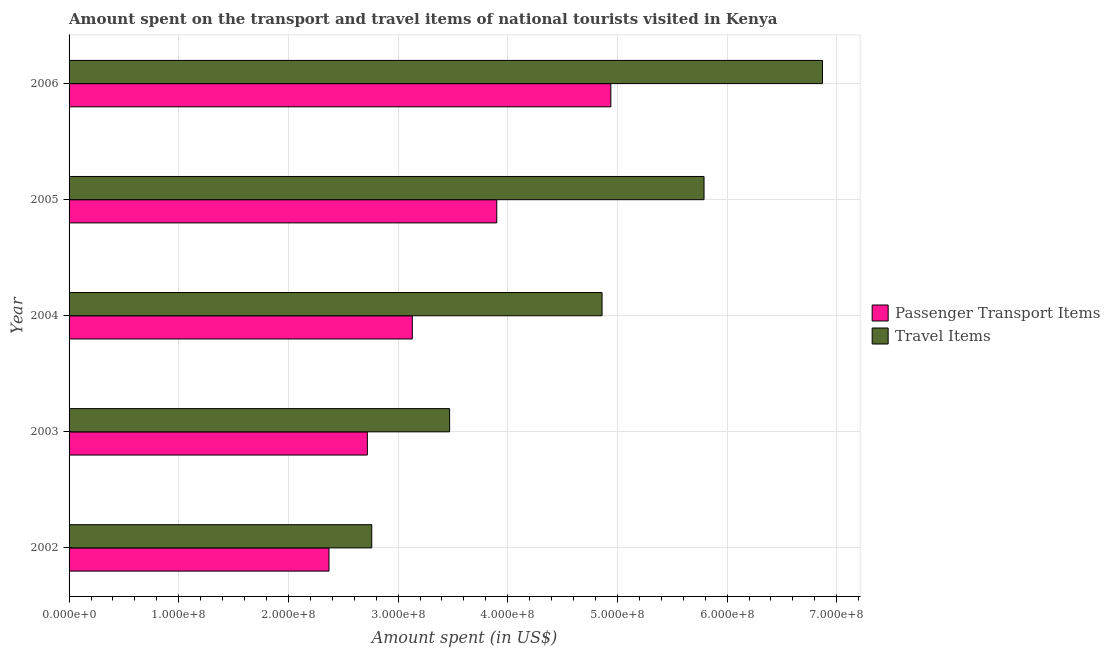How many different coloured bars are there?
Make the answer very short. 2. Are the number of bars per tick equal to the number of legend labels?
Provide a short and direct response. Yes. Are the number of bars on each tick of the Y-axis equal?
Give a very brief answer. Yes. What is the label of the 3rd group of bars from the top?
Your answer should be very brief. 2004. In how many cases, is the number of bars for a given year not equal to the number of legend labels?
Keep it short and to the point. 0. What is the amount spent in travel items in 2002?
Your answer should be very brief. 2.76e+08. Across all years, what is the maximum amount spent on passenger transport items?
Keep it short and to the point. 4.94e+08. Across all years, what is the minimum amount spent on passenger transport items?
Your response must be concise. 2.37e+08. In which year was the amount spent in travel items minimum?
Your response must be concise. 2002. What is the total amount spent in travel items in the graph?
Keep it short and to the point. 2.38e+09. What is the difference between the amount spent in travel items in 2002 and that in 2006?
Make the answer very short. -4.11e+08. What is the difference between the amount spent on passenger transport items in 2004 and the amount spent in travel items in 2003?
Give a very brief answer. -3.40e+07. What is the average amount spent in travel items per year?
Your response must be concise. 4.75e+08. In the year 2006, what is the difference between the amount spent in travel items and amount spent on passenger transport items?
Provide a short and direct response. 1.93e+08. In how many years, is the amount spent in travel items greater than 60000000 US$?
Your response must be concise. 5. What is the ratio of the amount spent in travel items in 2002 to that in 2005?
Provide a succinct answer. 0.48. Is the amount spent in travel items in 2003 less than that in 2004?
Offer a very short reply. Yes. Is the difference between the amount spent on passenger transport items in 2003 and 2005 greater than the difference between the amount spent in travel items in 2003 and 2005?
Give a very brief answer. Yes. What is the difference between the highest and the second highest amount spent in travel items?
Offer a terse response. 1.08e+08. What is the difference between the highest and the lowest amount spent on passenger transport items?
Make the answer very short. 2.57e+08. Is the sum of the amount spent on passenger transport items in 2004 and 2006 greater than the maximum amount spent in travel items across all years?
Offer a very short reply. Yes. What does the 1st bar from the top in 2003 represents?
Offer a very short reply. Travel Items. What does the 2nd bar from the bottom in 2005 represents?
Your answer should be compact. Travel Items. How many bars are there?
Your response must be concise. 10. How many years are there in the graph?
Provide a short and direct response. 5. Are the values on the major ticks of X-axis written in scientific E-notation?
Make the answer very short. Yes. Does the graph contain any zero values?
Your response must be concise. No. How are the legend labels stacked?
Give a very brief answer. Vertical. What is the title of the graph?
Provide a short and direct response. Amount spent on the transport and travel items of national tourists visited in Kenya. Does "Total Population" appear as one of the legend labels in the graph?
Make the answer very short. No. What is the label or title of the X-axis?
Your answer should be compact. Amount spent (in US$). What is the Amount spent (in US$) in Passenger Transport Items in 2002?
Provide a short and direct response. 2.37e+08. What is the Amount spent (in US$) in Travel Items in 2002?
Keep it short and to the point. 2.76e+08. What is the Amount spent (in US$) of Passenger Transport Items in 2003?
Keep it short and to the point. 2.72e+08. What is the Amount spent (in US$) in Travel Items in 2003?
Offer a very short reply. 3.47e+08. What is the Amount spent (in US$) of Passenger Transport Items in 2004?
Give a very brief answer. 3.13e+08. What is the Amount spent (in US$) of Travel Items in 2004?
Make the answer very short. 4.86e+08. What is the Amount spent (in US$) in Passenger Transport Items in 2005?
Give a very brief answer. 3.90e+08. What is the Amount spent (in US$) of Travel Items in 2005?
Offer a terse response. 5.79e+08. What is the Amount spent (in US$) in Passenger Transport Items in 2006?
Make the answer very short. 4.94e+08. What is the Amount spent (in US$) of Travel Items in 2006?
Offer a terse response. 6.87e+08. Across all years, what is the maximum Amount spent (in US$) of Passenger Transport Items?
Your answer should be very brief. 4.94e+08. Across all years, what is the maximum Amount spent (in US$) in Travel Items?
Make the answer very short. 6.87e+08. Across all years, what is the minimum Amount spent (in US$) of Passenger Transport Items?
Make the answer very short. 2.37e+08. Across all years, what is the minimum Amount spent (in US$) in Travel Items?
Your answer should be very brief. 2.76e+08. What is the total Amount spent (in US$) of Passenger Transport Items in the graph?
Your response must be concise. 1.71e+09. What is the total Amount spent (in US$) in Travel Items in the graph?
Your answer should be compact. 2.38e+09. What is the difference between the Amount spent (in US$) in Passenger Transport Items in 2002 and that in 2003?
Make the answer very short. -3.50e+07. What is the difference between the Amount spent (in US$) in Travel Items in 2002 and that in 2003?
Your answer should be very brief. -7.10e+07. What is the difference between the Amount spent (in US$) of Passenger Transport Items in 2002 and that in 2004?
Provide a short and direct response. -7.60e+07. What is the difference between the Amount spent (in US$) of Travel Items in 2002 and that in 2004?
Ensure brevity in your answer.  -2.10e+08. What is the difference between the Amount spent (in US$) in Passenger Transport Items in 2002 and that in 2005?
Provide a short and direct response. -1.53e+08. What is the difference between the Amount spent (in US$) in Travel Items in 2002 and that in 2005?
Keep it short and to the point. -3.03e+08. What is the difference between the Amount spent (in US$) in Passenger Transport Items in 2002 and that in 2006?
Offer a very short reply. -2.57e+08. What is the difference between the Amount spent (in US$) of Travel Items in 2002 and that in 2006?
Keep it short and to the point. -4.11e+08. What is the difference between the Amount spent (in US$) of Passenger Transport Items in 2003 and that in 2004?
Give a very brief answer. -4.10e+07. What is the difference between the Amount spent (in US$) in Travel Items in 2003 and that in 2004?
Give a very brief answer. -1.39e+08. What is the difference between the Amount spent (in US$) of Passenger Transport Items in 2003 and that in 2005?
Keep it short and to the point. -1.18e+08. What is the difference between the Amount spent (in US$) in Travel Items in 2003 and that in 2005?
Give a very brief answer. -2.32e+08. What is the difference between the Amount spent (in US$) of Passenger Transport Items in 2003 and that in 2006?
Offer a very short reply. -2.22e+08. What is the difference between the Amount spent (in US$) in Travel Items in 2003 and that in 2006?
Ensure brevity in your answer.  -3.40e+08. What is the difference between the Amount spent (in US$) of Passenger Transport Items in 2004 and that in 2005?
Keep it short and to the point. -7.70e+07. What is the difference between the Amount spent (in US$) in Travel Items in 2004 and that in 2005?
Give a very brief answer. -9.30e+07. What is the difference between the Amount spent (in US$) of Passenger Transport Items in 2004 and that in 2006?
Your answer should be very brief. -1.81e+08. What is the difference between the Amount spent (in US$) of Travel Items in 2004 and that in 2006?
Give a very brief answer. -2.01e+08. What is the difference between the Amount spent (in US$) in Passenger Transport Items in 2005 and that in 2006?
Give a very brief answer. -1.04e+08. What is the difference between the Amount spent (in US$) in Travel Items in 2005 and that in 2006?
Your response must be concise. -1.08e+08. What is the difference between the Amount spent (in US$) of Passenger Transport Items in 2002 and the Amount spent (in US$) of Travel Items in 2003?
Provide a short and direct response. -1.10e+08. What is the difference between the Amount spent (in US$) of Passenger Transport Items in 2002 and the Amount spent (in US$) of Travel Items in 2004?
Make the answer very short. -2.49e+08. What is the difference between the Amount spent (in US$) in Passenger Transport Items in 2002 and the Amount spent (in US$) in Travel Items in 2005?
Provide a succinct answer. -3.42e+08. What is the difference between the Amount spent (in US$) of Passenger Transport Items in 2002 and the Amount spent (in US$) of Travel Items in 2006?
Your response must be concise. -4.50e+08. What is the difference between the Amount spent (in US$) in Passenger Transport Items in 2003 and the Amount spent (in US$) in Travel Items in 2004?
Provide a succinct answer. -2.14e+08. What is the difference between the Amount spent (in US$) in Passenger Transport Items in 2003 and the Amount spent (in US$) in Travel Items in 2005?
Ensure brevity in your answer.  -3.07e+08. What is the difference between the Amount spent (in US$) in Passenger Transport Items in 2003 and the Amount spent (in US$) in Travel Items in 2006?
Offer a terse response. -4.15e+08. What is the difference between the Amount spent (in US$) in Passenger Transport Items in 2004 and the Amount spent (in US$) in Travel Items in 2005?
Offer a very short reply. -2.66e+08. What is the difference between the Amount spent (in US$) of Passenger Transport Items in 2004 and the Amount spent (in US$) of Travel Items in 2006?
Make the answer very short. -3.74e+08. What is the difference between the Amount spent (in US$) of Passenger Transport Items in 2005 and the Amount spent (in US$) of Travel Items in 2006?
Offer a very short reply. -2.97e+08. What is the average Amount spent (in US$) in Passenger Transport Items per year?
Your answer should be compact. 3.41e+08. What is the average Amount spent (in US$) in Travel Items per year?
Your answer should be compact. 4.75e+08. In the year 2002, what is the difference between the Amount spent (in US$) in Passenger Transport Items and Amount spent (in US$) in Travel Items?
Your answer should be compact. -3.90e+07. In the year 2003, what is the difference between the Amount spent (in US$) of Passenger Transport Items and Amount spent (in US$) of Travel Items?
Your answer should be very brief. -7.50e+07. In the year 2004, what is the difference between the Amount spent (in US$) in Passenger Transport Items and Amount spent (in US$) in Travel Items?
Ensure brevity in your answer.  -1.73e+08. In the year 2005, what is the difference between the Amount spent (in US$) in Passenger Transport Items and Amount spent (in US$) in Travel Items?
Your answer should be compact. -1.89e+08. In the year 2006, what is the difference between the Amount spent (in US$) of Passenger Transport Items and Amount spent (in US$) of Travel Items?
Provide a succinct answer. -1.93e+08. What is the ratio of the Amount spent (in US$) of Passenger Transport Items in 2002 to that in 2003?
Make the answer very short. 0.87. What is the ratio of the Amount spent (in US$) of Travel Items in 2002 to that in 2003?
Give a very brief answer. 0.8. What is the ratio of the Amount spent (in US$) of Passenger Transport Items in 2002 to that in 2004?
Ensure brevity in your answer.  0.76. What is the ratio of the Amount spent (in US$) in Travel Items in 2002 to that in 2004?
Your answer should be very brief. 0.57. What is the ratio of the Amount spent (in US$) of Passenger Transport Items in 2002 to that in 2005?
Provide a short and direct response. 0.61. What is the ratio of the Amount spent (in US$) in Travel Items in 2002 to that in 2005?
Ensure brevity in your answer.  0.48. What is the ratio of the Amount spent (in US$) in Passenger Transport Items in 2002 to that in 2006?
Ensure brevity in your answer.  0.48. What is the ratio of the Amount spent (in US$) in Travel Items in 2002 to that in 2006?
Offer a terse response. 0.4. What is the ratio of the Amount spent (in US$) in Passenger Transport Items in 2003 to that in 2004?
Keep it short and to the point. 0.87. What is the ratio of the Amount spent (in US$) of Travel Items in 2003 to that in 2004?
Provide a short and direct response. 0.71. What is the ratio of the Amount spent (in US$) in Passenger Transport Items in 2003 to that in 2005?
Give a very brief answer. 0.7. What is the ratio of the Amount spent (in US$) in Travel Items in 2003 to that in 2005?
Make the answer very short. 0.6. What is the ratio of the Amount spent (in US$) in Passenger Transport Items in 2003 to that in 2006?
Offer a very short reply. 0.55. What is the ratio of the Amount spent (in US$) in Travel Items in 2003 to that in 2006?
Offer a very short reply. 0.51. What is the ratio of the Amount spent (in US$) of Passenger Transport Items in 2004 to that in 2005?
Your answer should be very brief. 0.8. What is the ratio of the Amount spent (in US$) in Travel Items in 2004 to that in 2005?
Offer a very short reply. 0.84. What is the ratio of the Amount spent (in US$) in Passenger Transport Items in 2004 to that in 2006?
Your response must be concise. 0.63. What is the ratio of the Amount spent (in US$) in Travel Items in 2004 to that in 2006?
Provide a succinct answer. 0.71. What is the ratio of the Amount spent (in US$) of Passenger Transport Items in 2005 to that in 2006?
Ensure brevity in your answer.  0.79. What is the ratio of the Amount spent (in US$) in Travel Items in 2005 to that in 2006?
Make the answer very short. 0.84. What is the difference between the highest and the second highest Amount spent (in US$) of Passenger Transport Items?
Your response must be concise. 1.04e+08. What is the difference between the highest and the second highest Amount spent (in US$) of Travel Items?
Provide a succinct answer. 1.08e+08. What is the difference between the highest and the lowest Amount spent (in US$) in Passenger Transport Items?
Offer a terse response. 2.57e+08. What is the difference between the highest and the lowest Amount spent (in US$) in Travel Items?
Your response must be concise. 4.11e+08. 